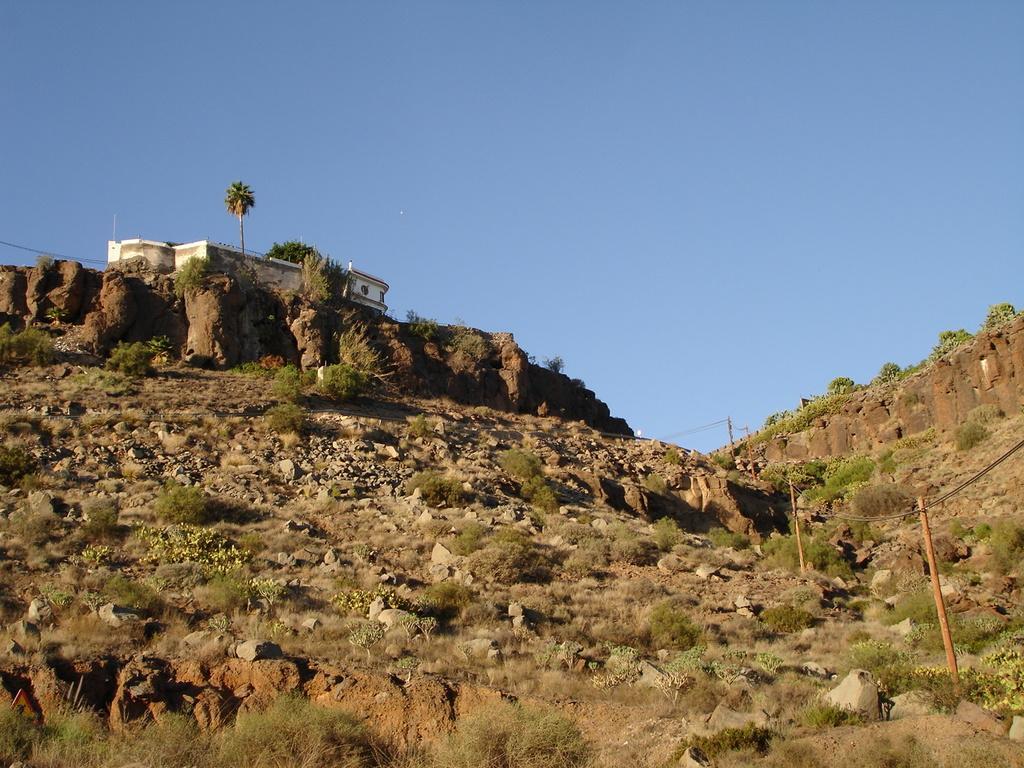Could you give a brief overview of what you see in this image? In this image I can see there is a mountain and there is a building on the cliff and there are few plants, trees, rocks and the sky is clear. 